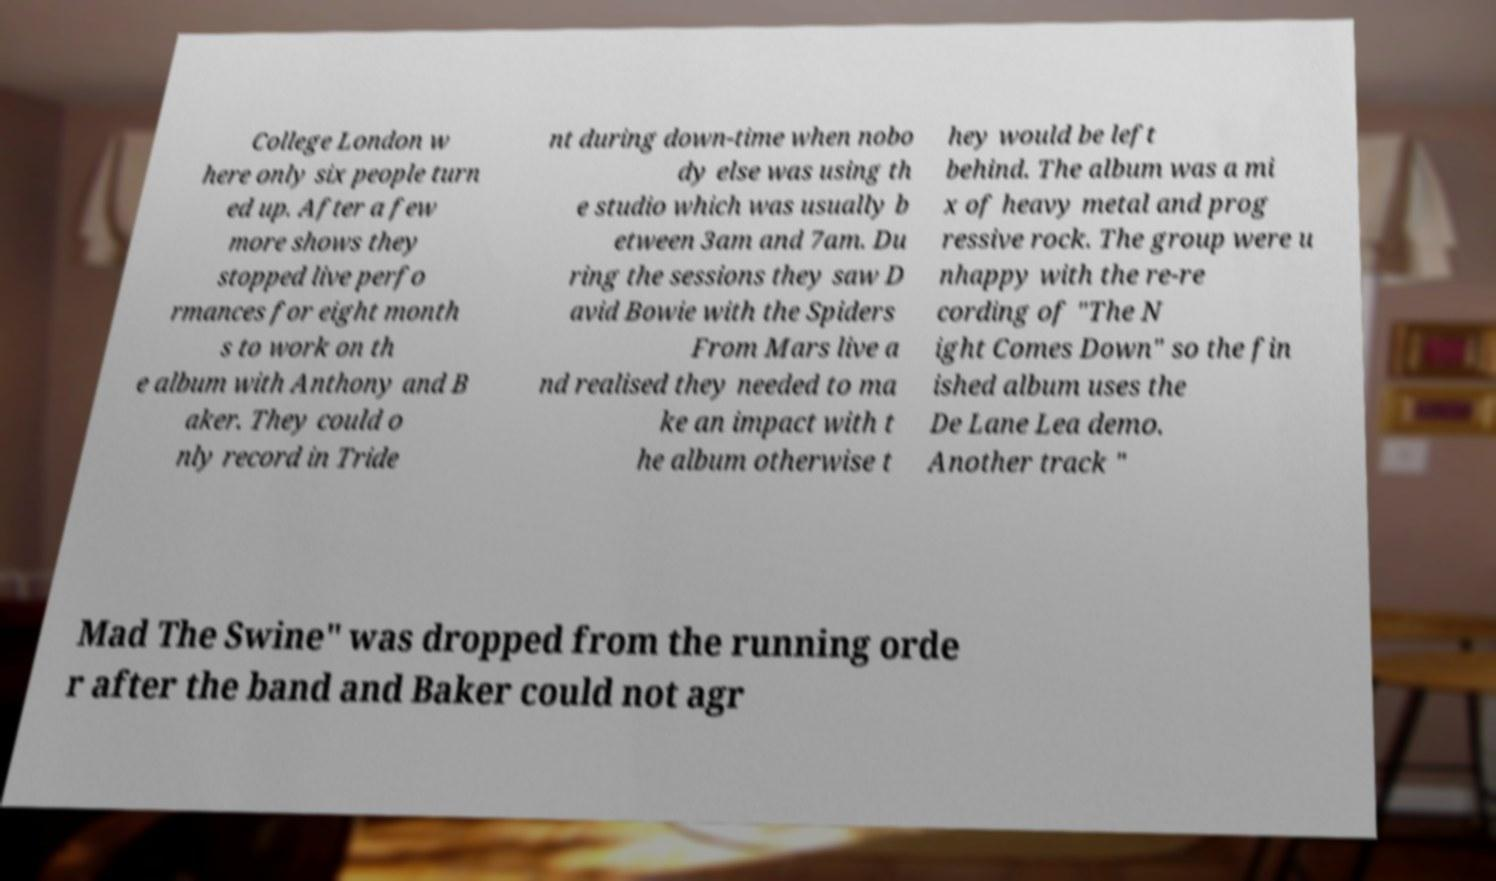I need the written content from this picture converted into text. Can you do that? College London w here only six people turn ed up. After a few more shows they stopped live perfo rmances for eight month s to work on th e album with Anthony and B aker. They could o nly record in Tride nt during down-time when nobo dy else was using th e studio which was usually b etween 3am and 7am. Du ring the sessions they saw D avid Bowie with the Spiders From Mars live a nd realised they needed to ma ke an impact with t he album otherwise t hey would be left behind. The album was a mi x of heavy metal and prog ressive rock. The group were u nhappy with the re-re cording of "The N ight Comes Down" so the fin ished album uses the De Lane Lea demo. Another track " Mad The Swine" was dropped from the running orde r after the band and Baker could not agr 